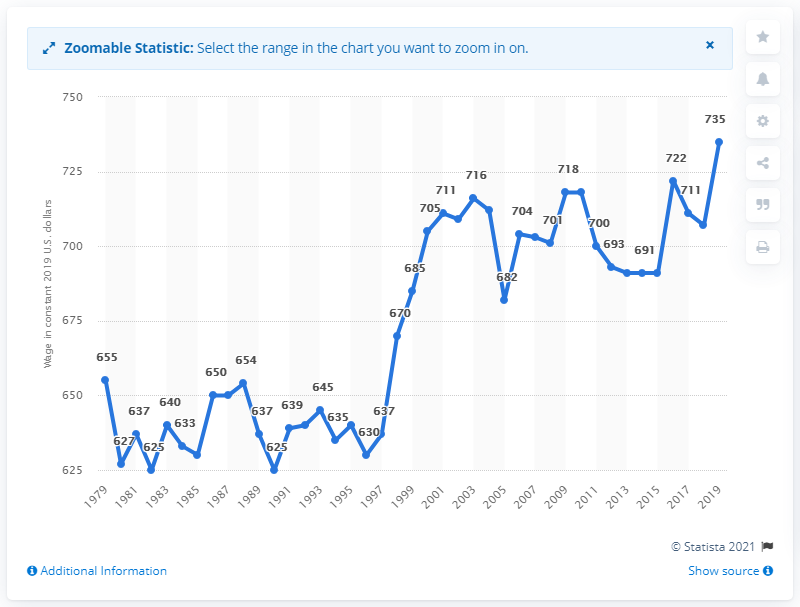Identify some key points in this picture. The median weekly earnings of an African American full-time employee in the United States in 2019 was $735. The year on which the dollar value is based is 2019. 